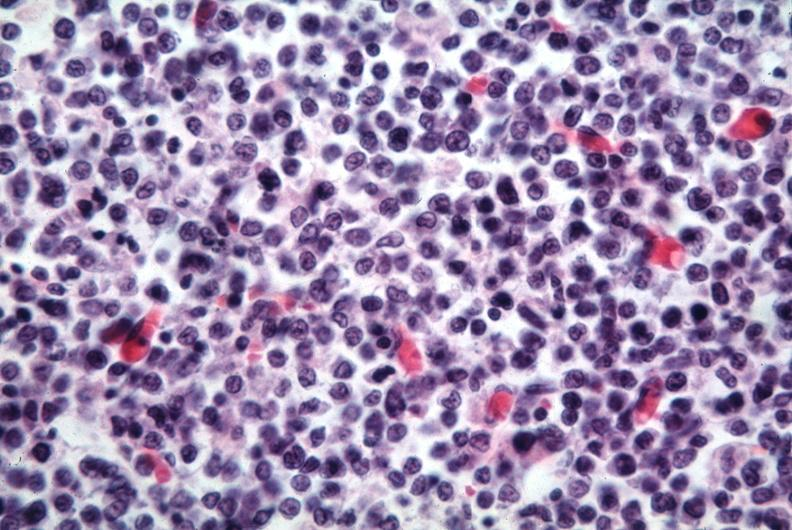what is present?
Answer the question using a single word or phrase. Lymph node 